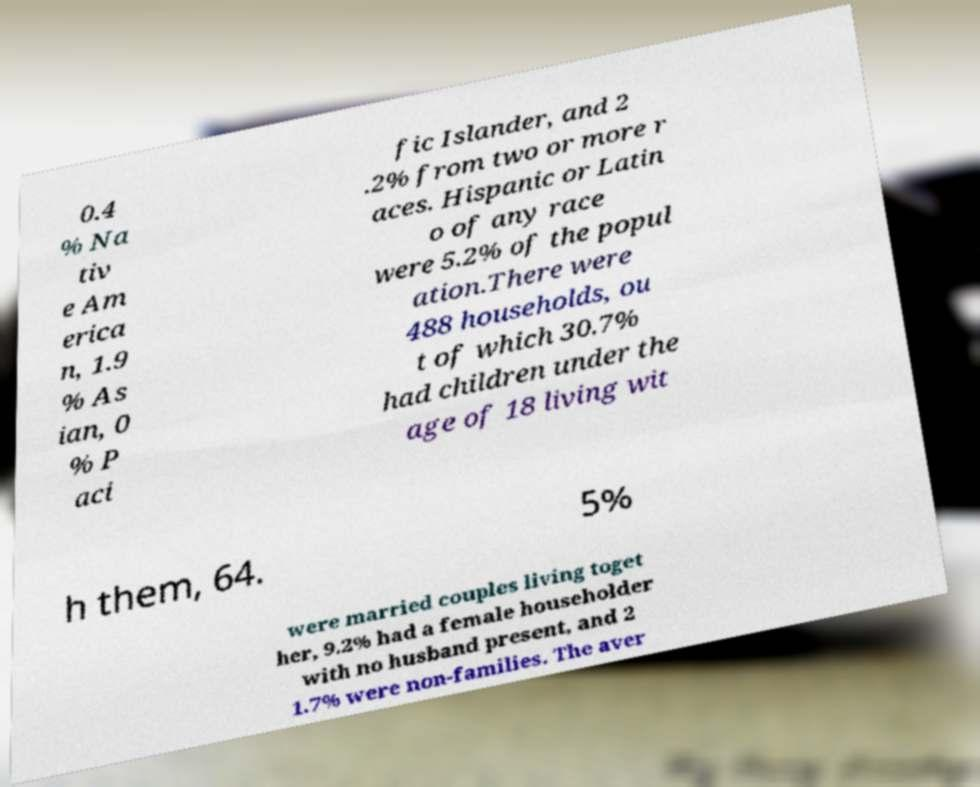What messages or text are displayed in this image? I need them in a readable, typed format. 0.4 % Na tiv e Am erica n, 1.9 % As ian, 0 % P aci fic Islander, and 2 .2% from two or more r aces. Hispanic or Latin o of any race were 5.2% of the popul ation.There were 488 households, ou t of which 30.7% had children under the age of 18 living wit h them, 64. 5% were married couples living toget her, 9.2% had a female householder with no husband present, and 2 1.7% were non-families. The aver 